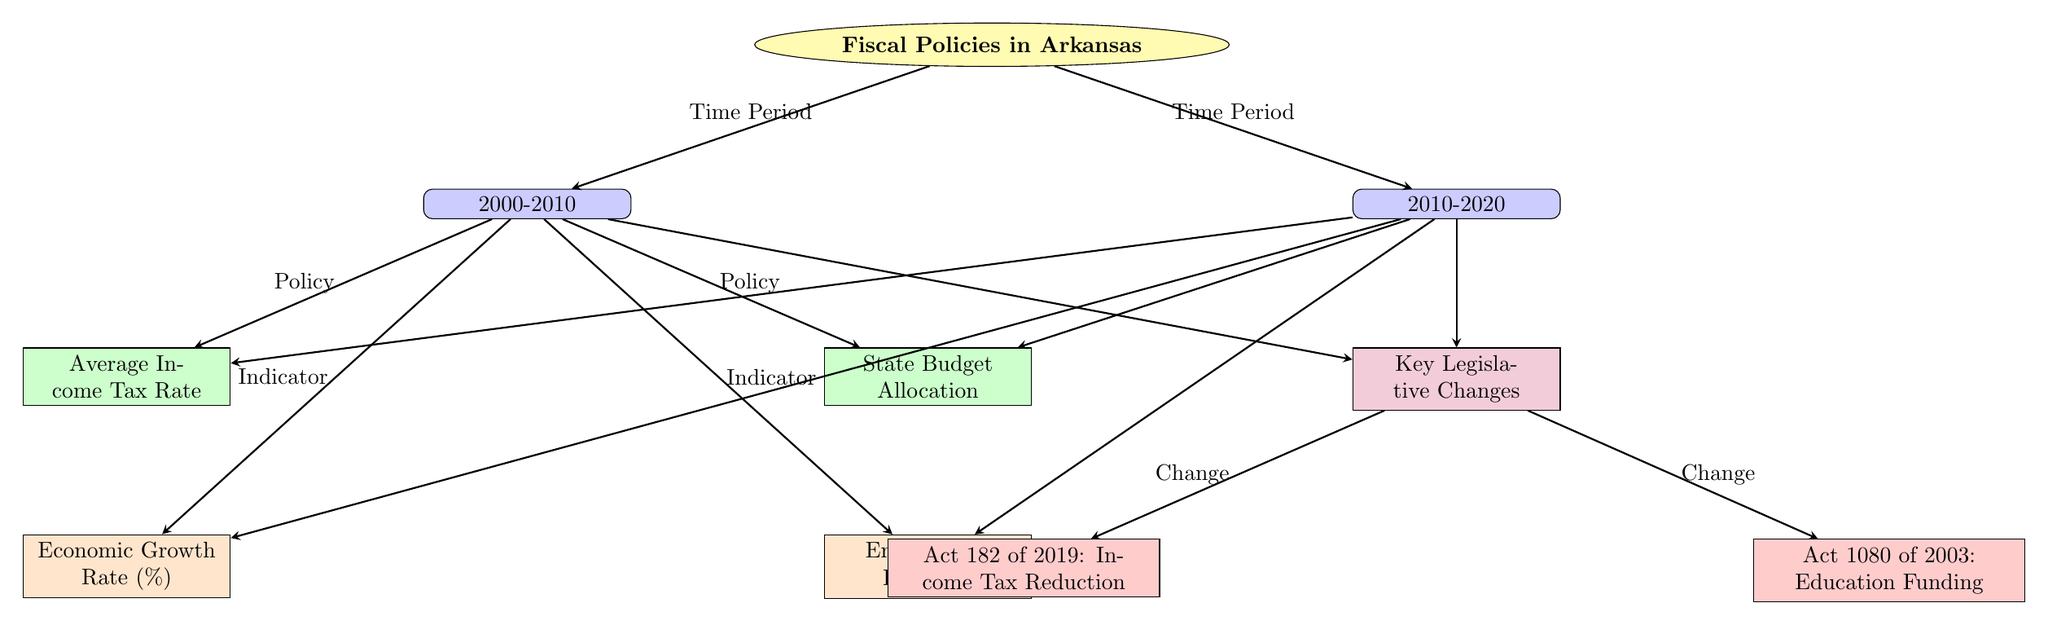What time periods are represented in the diagram? The diagram represents two time periods: 2000-2010 and 2010-2020, indicated by the nodes labeled with the respective decades.
Answer: 2000-2010 and 2010-2020 How many key legislative changes are shown in the diagram? The diagram shows two key legislative changes, represented by the nodes Act 182 of 2019 and Act 1080 of 2003.
Answer: 2 What is the color representing policies in the diagram? Policies are represented in green, as indicated by the fill color of the policy nodes in the diagram.
Answer: Green Which indicator is associated with the average income tax rate in 2000-2010? The economic growth rate is associated with the average income tax rate in the 2000-2010 period, indicated by the arrow connecting those two nodes.
Answer: Economic Growth Rate (%) What legislative change occurred in 2019 according to the diagram? Act 182 of 2019: Income Tax Reduction is the legislative change noted for 2019, shown in the diagram under the legislative changes node.
Answer: Act 182 of 2019: Income Tax Reduction In which decade was the education funding policy introduced? The education funding policy, represented by Act 1080 of 2003, was introduced in the 2000-2010 decade, as indicated by the connections in the diagram.
Answer: 2000-2010 How do both decades relate to key legislative changes? Both decades (2000-2010 and 2010-2020) are connected to the node that indicates key legislative changes, showing that legislation affected fiscal policies in both periods.
Answer: Both decades connect to legislation Which fiscal indicator is linked to the state budget allocation in the 2010-2020 period? The employment rate is linked to the state budget allocation for the 2010-2020 period, as shown by the arrows connecting those nodes.
Answer: Employment Rate (%) 